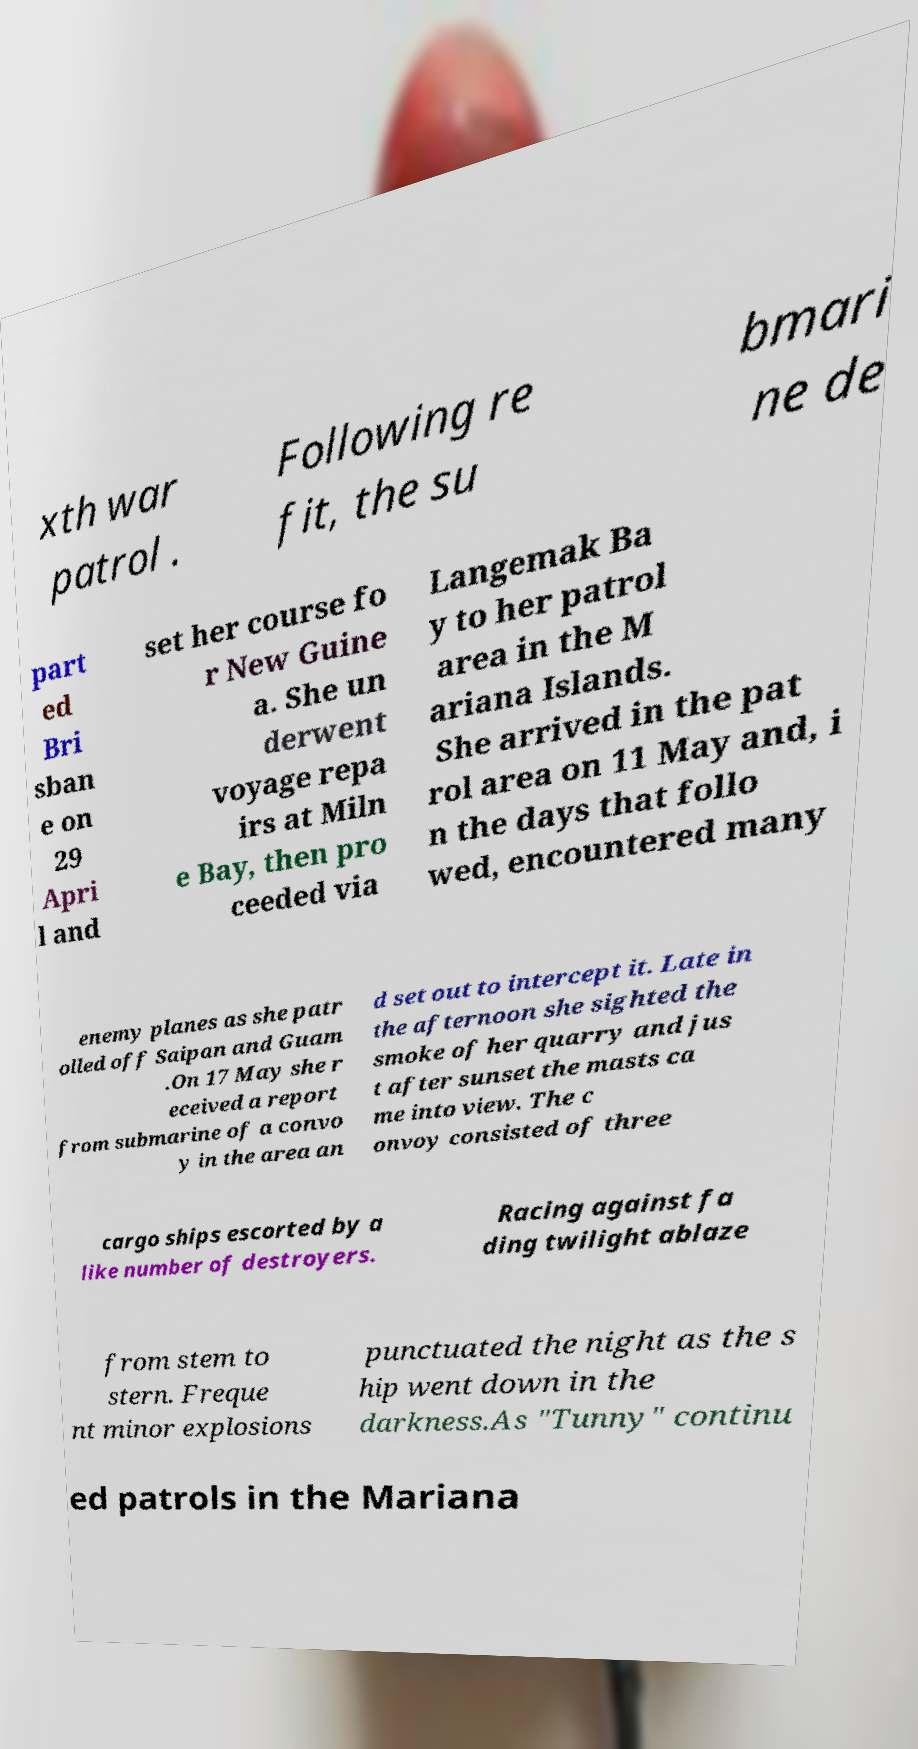I need the written content from this picture converted into text. Can you do that? xth war patrol . Following re fit, the su bmari ne de part ed Bri sban e on 29 Apri l and set her course fo r New Guine a. She un derwent voyage repa irs at Miln e Bay, then pro ceeded via Langemak Ba y to her patrol area in the M ariana Islands. She arrived in the pat rol area on 11 May and, i n the days that follo wed, encountered many enemy planes as she patr olled off Saipan and Guam .On 17 May she r eceived a report from submarine of a convo y in the area an d set out to intercept it. Late in the afternoon she sighted the smoke of her quarry and jus t after sunset the masts ca me into view. The c onvoy consisted of three cargo ships escorted by a like number of destroyers. Racing against fa ding twilight ablaze from stem to stern. Freque nt minor explosions punctuated the night as the s hip went down in the darkness.As "Tunny" continu ed patrols in the Mariana 